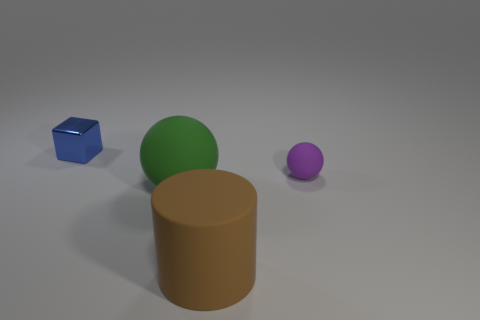Add 3 large red metallic spheres. How many objects exist? 7 Subtract all blocks. How many objects are left? 3 Add 1 brown things. How many brown things exist? 2 Subtract 1 brown cylinders. How many objects are left? 3 Subtract all green objects. Subtract all rubber cylinders. How many objects are left? 2 Add 4 objects. How many objects are left? 8 